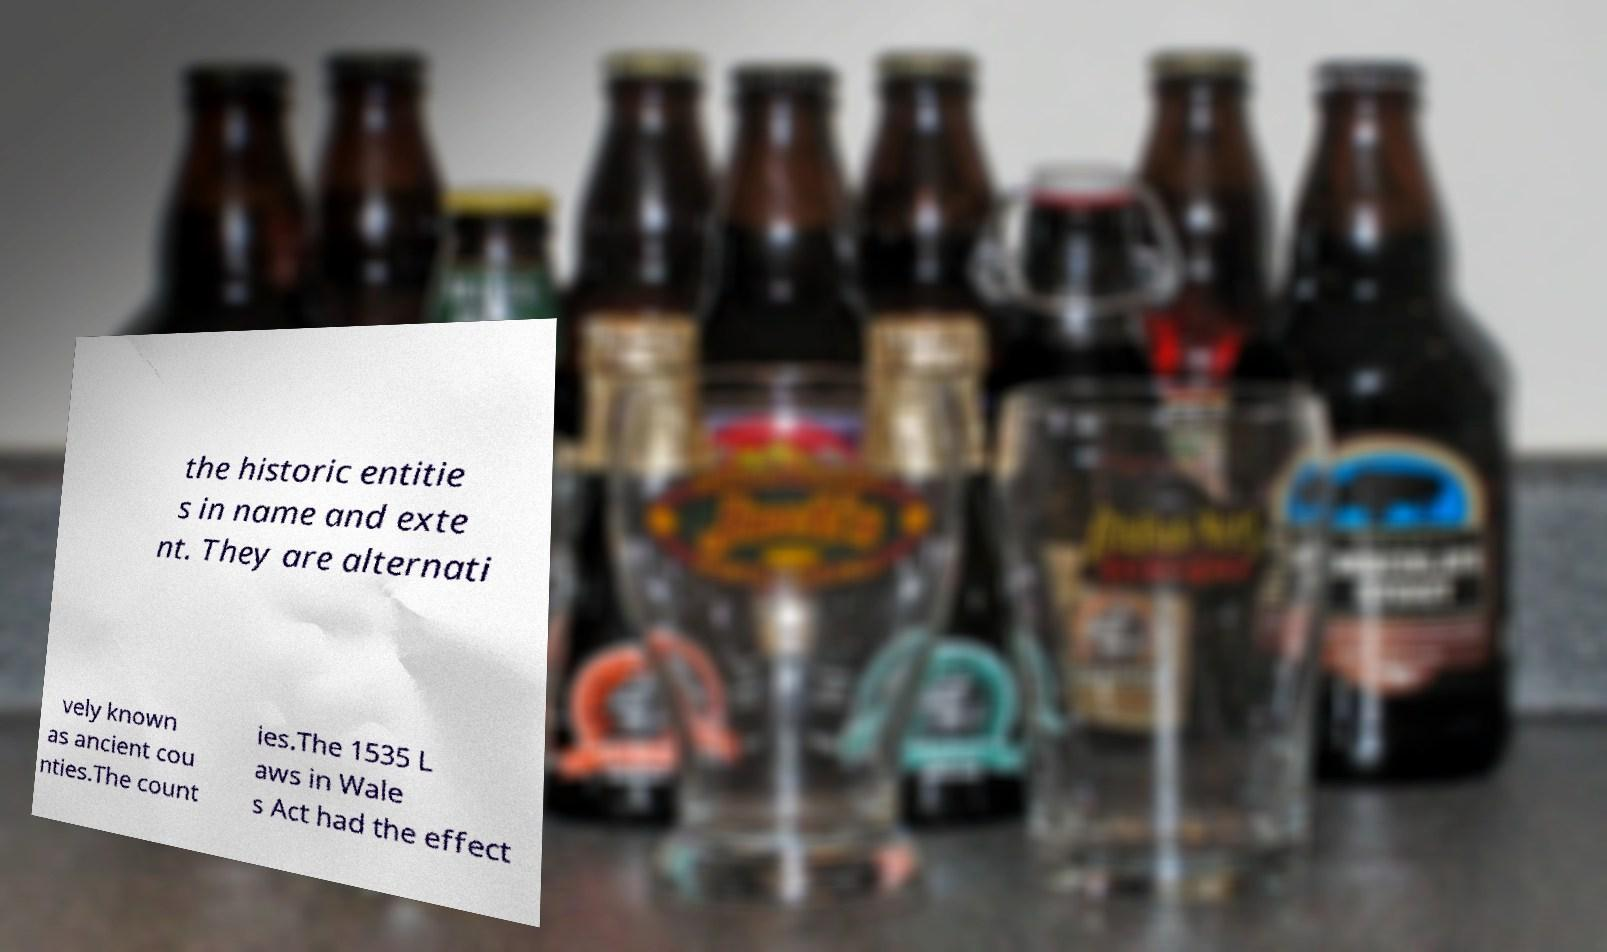What messages or text are displayed in this image? I need them in a readable, typed format. the historic entitie s in name and exte nt. They are alternati vely known as ancient cou nties.The count ies.The 1535 L aws in Wale s Act had the effect 